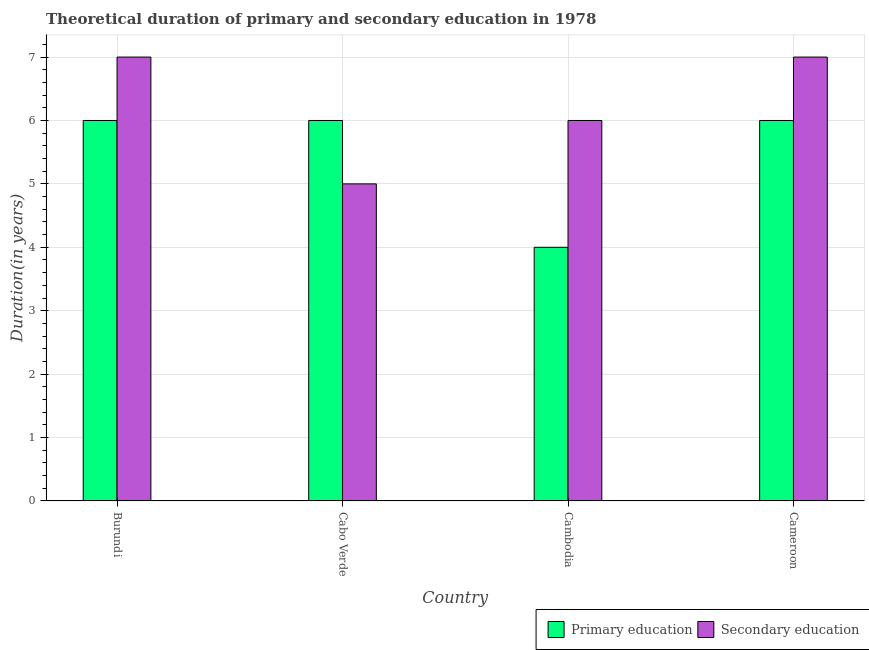How many different coloured bars are there?
Ensure brevity in your answer.  2. How many groups of bars are there?
Offer a terse response. 4. Are the number of bars per tick equal to the number of legend labels?
Your response must be concise. Yes. Are the number of bars on each tick of the X-axis equal?
Provide a succinct answer. Yes. What is the label of the 1st group of bars from the left?
Ensure brevity in your answer.  Burundi. What is the duration of secondary education in Cambodia?
Give a very brief answer. 6. Across all countries, what is the minimum duration of primary education?
Your answer should be very brief. 4. In which country was the duration of primary education maximum?
Give a very brief answer. Burundi. In which country was the duration of secondary education minimum?
Your answer should be compact. Cabo Verde. What is the total duration of secondary education in the graph?
Offer a very short reply. 25. What is the difference between the duration of secondary education in Burundi and that in Cameroon?
Give a very brief answer. 0. What is the difference between the duration of secondary education in Cabo Verde and the duration of primary education in Cameroon?
Your answer should be compact. -1. What is the average duration of primary education per country?
Offer a terse response. 5.5. What is the difference between the duration of secondary education and duration of primary education in Cameroon?
Offer a terse response. 1. In how many countries, is the duration of secondary education greater than 6.4 years?
Provide a short and direct response. 2. Is the difference between the duration of secondary education in Cabo Verde and Cambodia greater than the difference between the duration of primary education in Cabo Verde and Cambodia?
Ensure brevity in your answer.  No. What is the difference between the highest and the lowest duration of secondary education?
Give a very brief answer. 2. In how many countries, is the duration of primary education greater than the average duration of primary education taken over all countries?
Provide a short and direct response. 3. Is the sum of the duration of primary education in Burundi and Cameroon greater than the maximum duration of secondary education across all countries?
Ensure brevity in your answer.  Yes. What does the 2nd bar from the left in Cambodia represents?
Your response must be concise. Secondary education. What does the 1st bar from the right in Cambodia represents?
Your answer should be compact. Secondary education. Are all the bars in the graph horizontal?
Your answer should be compact. No. What is the difference between two consecutive major ticks on the Y-axis?
Provide a short and direct response. 1. Are the values on the major ticks of Y-axis written in scientific E-notation?
Your answer should be compact. No. Does the graph contain any zero values?
Make the answer very short. No. Does the graph contain grids?
Offer a very short reply. Yes. Where does the legend appear in the graph?
Offer a terse response. Bottom right. What is the title of the graph?
Your answer should be compact. Theoretical duration of primary and secondary education in 1978. What is the label or title of the X-axis?
Offer a very short reply. Country. What is the label or title of the Y-axis?
Ensure brevity in your answer.  Duration(in years). What is the Duration(in years) in Primary education in Burundi?
Provide a succinct answer. 6. What is the Duration(in years) in Secondary education in Cabo Verde?
Your answer should be compact. 5. What is the Duration(in years) in Secondary education in Cambodia?
Make the answer very short. 6. What is the Duration(in years) in Primary education in Cameroon?
Offer a very short reply. 6. What is the Duration(in years) in Secondary education in Cameroon?
Provide a succinct answer. 7. Across all countries, what is the maximum Duration(in years) in Secondary education?
Make the answer very short. 7. Across all countries, what is the minimum Duration(in years) of Secondary education?
Your answer should be very brief. 5. What is the total Duration(in years) in Primary education in the graph?
Make the answer very short. 22. What is the difference between the Duration(in years) of Secondary education in Burundi and that in Cabo Verde?
Your answer should be very brief. 2. What is the difference between the Duration(in years) of Primary education in Burundi and that in Cambodia?
Give a very brief answer. 2. What is the difference between the Duration(in years) of Primary education in Cabo Verde and that in Cambodia?
Offer a terse response. 2. What is the difference between the Duration(in years) in Primary education in Cabo Verde and that in Cameroon?
Make the answer very short. 0. What is the difference between the Duration(in years) in Secondary education in Cabo Verde and that in Cameroon?
Provide a short and direct response. -2. What is the difference between the Duration(in years) in Primary education in Cambodia and that in Cameroon?
Ensure brevity in your answer.  -2. What is the difference between the Duration(in years) in Secondary education in Cambodia and that in Cameroon?
Ensure brevity in your answer.  -1. What is the difference between the Duration(in years) of Primary education in Cabo Verde and the Duration(in years) of Secondary education in Cambodia?
Offer a very short reply. 0. What is the difference between the Duration(in years) of Primary education in Cabo Verde and the Duration(in years) of Secondary education in Cameroon?
Your response must be concise. -1. What is the average Duration(in years) in Primary education per country?
Keep it short and to the point. 5.5. What is the average Duration(in years) in Secondary education per country?
Offer a terse response. 6.25. What is the difference between the Duration(in years) of Primary education and Duration(in years) of Secondary education in Cabo Verde?
Offer a very short reply. 1. What is the difference between the Duration(in years) in Primary education and Duration(in years) in Secondary education in Cambodia?
Provide a succinct answer. -2. What is the difference between the Duration(in years) in Primary education and Duration(in years) in Secondary education in Cameroon?
Keep it short and to the point. -1. What is the ratio of the Duration(in years) of Primary education in Burundi to that in Cameroon?
Ensure brevity in your answer.  1. What is the ratio of the Duration(in years) of Secondary education in Burundi to that in Cameroon?
Provide a succinct answer. 1. What is the ratio of the Duration(in years) in Primary education in Cabo Verde to that in Cambodia?
Make the answer very short. 1.5. What is the ratio of the Duration(in years) of Primary education in Cabo Verde to that in Cameroon?
Keep it short and to the point. 1. What is the ratio of the Duration(in years) in Primary education in Cambodia to that in Cameroon?
Keep it short and to the point. 0.67. What is the difference between the highest and the second highest Duration(in years) of Primary education?
Give a very brief answer. 0. What is the difference between the highest and the second highest Duration(in years) of Secondary education?
Make the answer very short. 0. What is the difference between the highest and the lowest Duration(in years) in Primary education?
Your answer should be very brief. 2. What is the difference between the highest and the lowest Duration(in years) of Secondary education?
Keep it short and to the point. 2. 